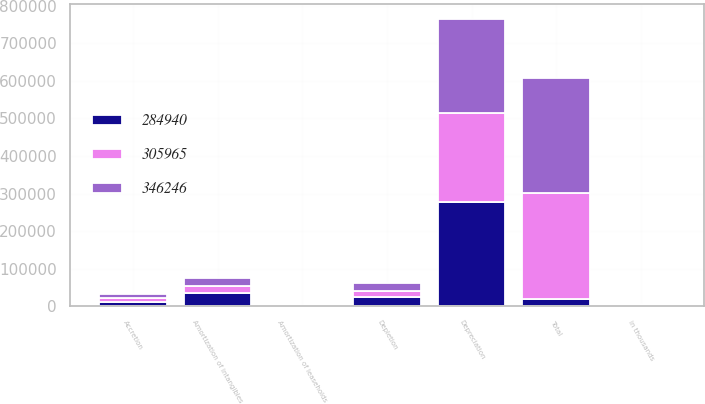<chart> <loc_0><loc_0><loc_500><loc_500><stacked_bar_chart><ecel><fcel>in thousands<fcel>Depreciation<fcel>Depletion<fcel>Accretion<fcel>Amortization of leaseholds<fcel>Amortization of intangibles<fcel>Total<nl><fcel>284940<fcel>2018<fcel>276814<fcel>23260<fcel>10776<fcel>472<fcel>34924<fcel>17688.5<nl><fcel>346246<fcel>2017<fcel>250835<fcel>19342<fcel>11415<fcel>608<fcel>23765<fcel>305965<nl><fcel>305965<fcel>2016<fcel>238237<fcel>17812<fcel>11059<fcel>267<fcel>17565<fcel>284940<nl></chart> 